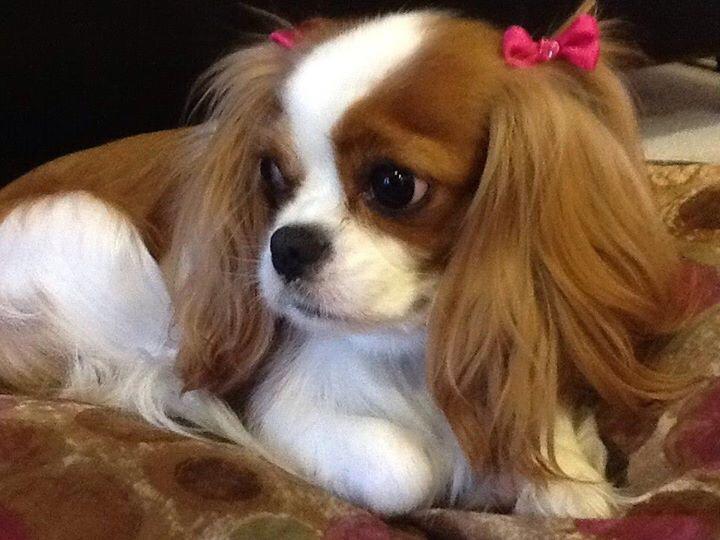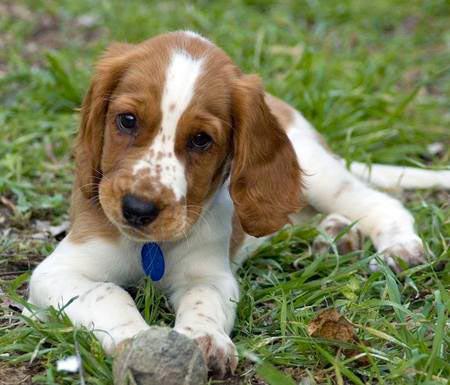The first image is the image on the left, the second image is the image on the right. Assess this claim about the two images: "The dog on the left is sitting on the grass.". Correct or not? Answer yes or no. No. The first image is the image on the left, the second image is the image on the right. For the images shown, is this caption "An image shows a puppy reclining on the grass with head lifted." true? Answer yes or no. Yes. 